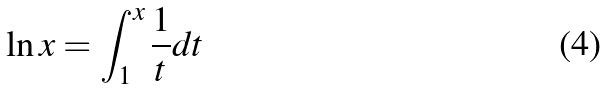Convert formula to latex. <formula><loc_0><loc_0><loc_500><loc_500>\ln x = \int _ { 1 } ^ { x } \frac { 1 } { t } d t</formula> 